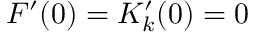Convert formula to latex. <formula><loc_0><loc_0><loc_500><loc_500>F ^ { \prime } ( 0 ) = K _ { k } ^ { \prime } ( 0 ) = 0</formula> 